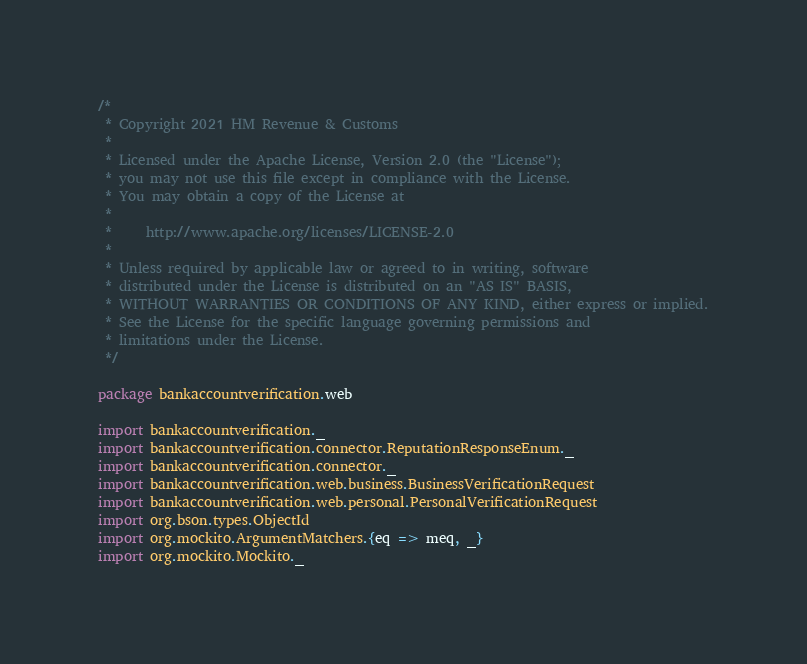<code> <loc_0><loc_0><loc_500><loc_500><_Scala_>/*
 * Copyright 2021 HM Revenue & Customs
 *
 * Licensed under the Apache License, Version 2.0 (the "License");
 * you may not use this file except in compliance with the License.
 * You may obtain a copy of the License at
 *
 *     http://www.apache.org/licenses/LICENSE-2.0
 *
 * Unless required by applicable law or agreed to in writing, software
 * distributed under the License is distributed on an "AS IS" BASIS,
 * WITHOUT WARRANTIES OR CONDITIONS OF ANY KIND, either express or implied.
 * See the License for the specific language governing permissions and
 * limitations under the License.
 */

package bankaccountverification.web

import bankaccountverification._
import bankaccountverification.connector.ReputationResponseEnum._
import bankaccountverification.connector._
import bankaccountverification.web.business.BusinessVerificationRequest
import bankaccountverification.web.personal.PersonalVerificationRequest
import org.bson.types.ObjectId
import org.mockito.ArgumentMatchers.{eq => meq, _}
import org.mockito.Mockito._</code> 